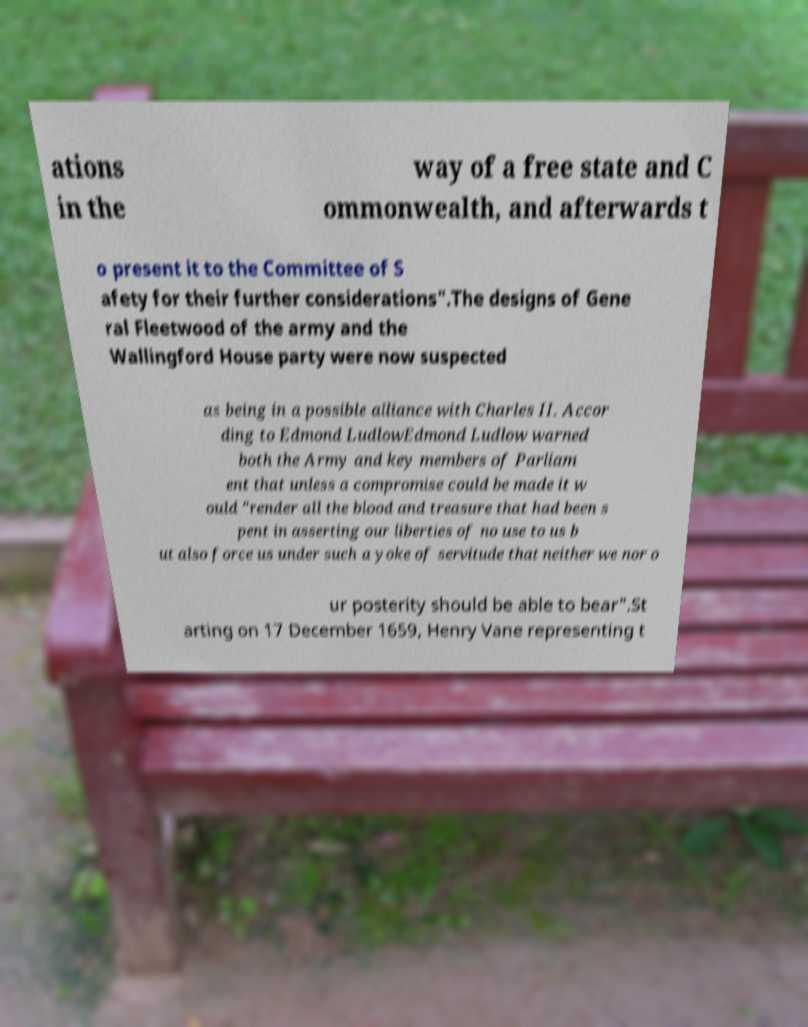For documentation purposes, I need the text within this image transcribed. Could you provide that? ations in the way of a free state and C ommonwealth, and afterwards t o present it to the Committee of S afety for their further considerations".The designs of Gene ral Fleetwood of the army and the Wallingford House party were now suspected as being in a possible alliance with Charles II. Accor ding to Edmond LudlowEdmond Ludlow warned both the Army and key members of Parliam ent that unless a compromise could be made it w ould "render all the blood and treasure that had been s pent in asserting our liberties of no use to us b ut also force us under such a yoke of servitude that neither we nor o ur posterity should be able to bear".St arting on 17 December 1659, Henry Vane representing t 